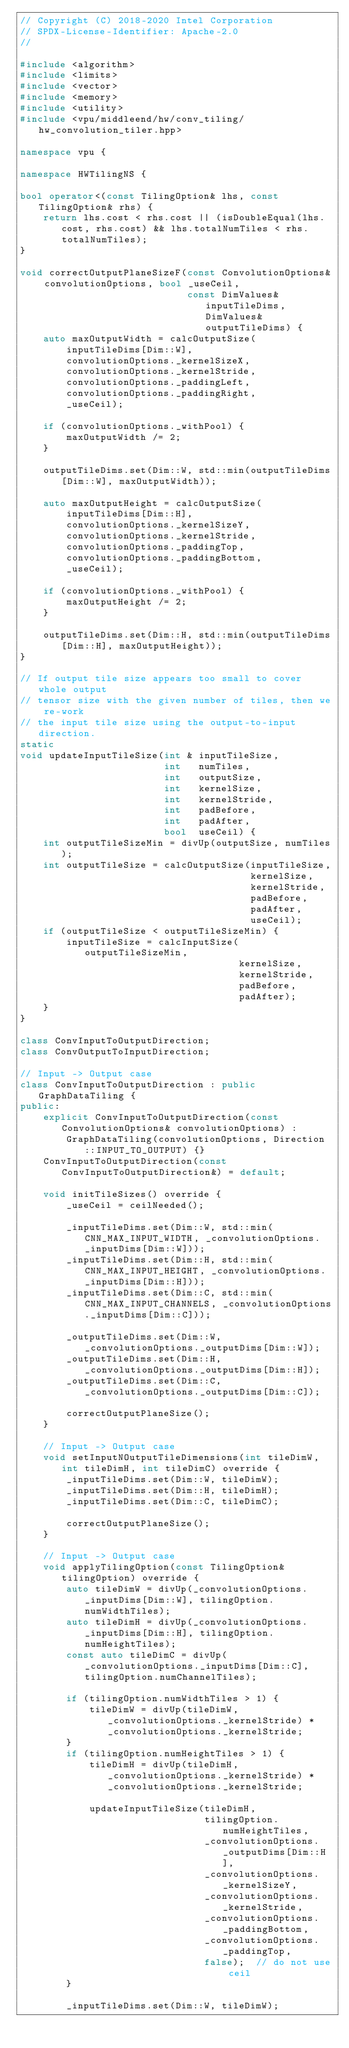<code> <loc_0><loc_0><loc_500><loc_500><_C++_>// Copyright (C) 2018-2020 Intel Corporation
// SPDX-License-Identifier: Apache-2.0
//

#include <algorithm>
#include <limits>
#include <vector>
#include <memory>
#include <utility>
#include <vpu/middleend/hw/conv_tiling/hw_convolution_tiler.hpp>

namespace vpu {

namespace HWTilingNS {

bool operator<(const TilingOption& lhs, const TilingOption& rhs) {
    return lhs.cost < rhs.cost || (isDoubleEqual(lhs.cost, rhs.cost) && lhs.totalNumTiles < rhs.totalNumTiles);
}

void correctOutputPlaneSizeF(const ConvolutionOptions& convolutionOptions, bool _useCeil,
                             const DimValues& inputTileDims, DimValues& outputTileDims) {
    auto maxOutputWidth = calcOutputSize(
        inputTileDims[Dim::W],
        convolutionOptions._kernelSizeX,
        convolutionOptions._kernelStride,
        convolutionOptions._paddingLeft,
        convolutionOptions._paddingRight,
        _useCeil);

    if (convolutionOptions._withPool) {
        maxOutputWidth /= 2;
    }

    outputTileDims.set(Dim::W, std::min(outputTileDims[Dim::W], maxOutputWidth));

    auto maxOutputHeight = calcOutputSize(
        inputTileDims[Dim::H],
        convolutionOptions._kernelSizeY,
        convolutionOptions._kernelStride,
        convolutionOptions._paddingTop,
        convolutionOptions._paddingBottom,
        _useCeil);

    if (convolutionOptions._withPool) {
        maxOutputHeight /= 2;
    }

    outputTileDims.set(Dim::H, std::min(outputTileDims[Dim::H], maxOutputHeight));
}

// If output tile size appears too small to cover whole output
// tensor size with the given number of tiles, then we re-work
// the input tile size using the output-to-input direction.
static
void updateInputTileSize(int & inputTileSize,
                         int   numTiles,
                         int   outputSize,
                         int   kernelSize,
                         int   kernelStride,
                         int   padBefore,
                         int   padAfter,
                         bool  useCeil) {
    int outputTileSizeMin = divUp(outputSize, numTiles);
    int outputTileSize = calcOutputSize(inputTileSize,
                                        kernelSize,
                                        kernelStride,
                                        padBefore,
                                        padAfter,
                                        useCeil);
    if (outputTileSize < outputTileSizeMin) {
        inputTileSize = calcInputSize(outputTileSizeMin,
                                      kernelSize,
                                      kernelStride,
                                      padBefore,
                                      padAfter);
    }
}

class ConvInputToOutputDirection;
class ConvOutputToInputDirection;

// Input -> Output case
class ConvInputToOutputDirection : public GraphDataTiling {
public:
    explicit ConvInputToOutputDirection(const ConvolutionOptions& convolutionOptions) :
        GraphDataTiling(convolutionOptions, Direction::INPUT_TO_OUTPUT) {}
    ConvInputToOutputDirection(const ConvInputToOutputDirection&) = default;

    void initTileSizes() override {
        _useCeil = ceilNeeded();

        _inputTileDims.set(Dim::W, std::min(CNN_MAX_INPUT_WIDTH, _convolutionOptions._inputDims[Dim::W]));
        _inputTileDims.set(Dim::H, std::min(CNN_MAX_INPUT_HEIGHT, _convolutionOptions._inputDims[Dim::H]));
        _inputTileDims.set(Dim::C, std::min(CNN_MAX_INPUT_CHANNELS, _convolutionOptions._inputDims[Dim::C]));

        _outputTileDims.set(Dim::W, _convolutionOptions._outputDims[Dim::W]);
        _outputTileDims.set(Dim::H, _convolutionOptions._outputDims[Dim::H]);
        _outputTileDims.set(Dim::C, _convolutionOptions._outputDims[Dim::C]);

        correctOutputPlaneSize();
    }

    // Input -> Output case
    void setInputNOutputTileDimensions(int tileDimW, int tileDimH, int tileDimC) override {
        _inputTileDims.set(Dim::W, tileDimW);
        _inputTileDims.set(Dim::H, tileDimH);
        _inputTileDims.set(Dim::C, tileDimC);

        correctOutputPlaneSize();
    }

    // Input -> Output case
    void applyTilingOption(const TilingOption& tilingOption) override {
        auto tileDimW = divUp(_convolutionOptions._inputDims[Dim::W], tilingOption.numWidthTiles);
        auto tileDimH = divUp(_convolutionOptions._inputDims[Dim::H], tilingOption.numHeightTiles);
        const auto tileDimC = divUp(_convolutionOptions._inputDims[Dim::C], tilingOption.numChannelTiles);

        if (tilingOption.numWidthTiles > 1) {
            tileDimW = divUp(tileDimW, _convolutionOptions._kernelStride) * _convolutionOptions._kernelStride;
        }
        if (tilingOption.numHeightTiles > 1) {
            tileDimH = divUp(tileDimH, _convolutionOptions._kernelStride) * _convolutionOptions._kernelStride;

            updateInputTileSize(tileDimH,
                                tilingOption.numHeightTiles,
                                _convolutionOptions._outputDims[Dim::H],
                                _convolutionOptions._kernelSizeY,
                                _convolutionOptions._kernelStride,
                                _convolutionOptions._paddingBottom,
                                _convolutionOptions._paddingTop,
                                false);  // do not use ceil
        }

        _inputTileDims.set(Dim::W, tileDimW);</code> 